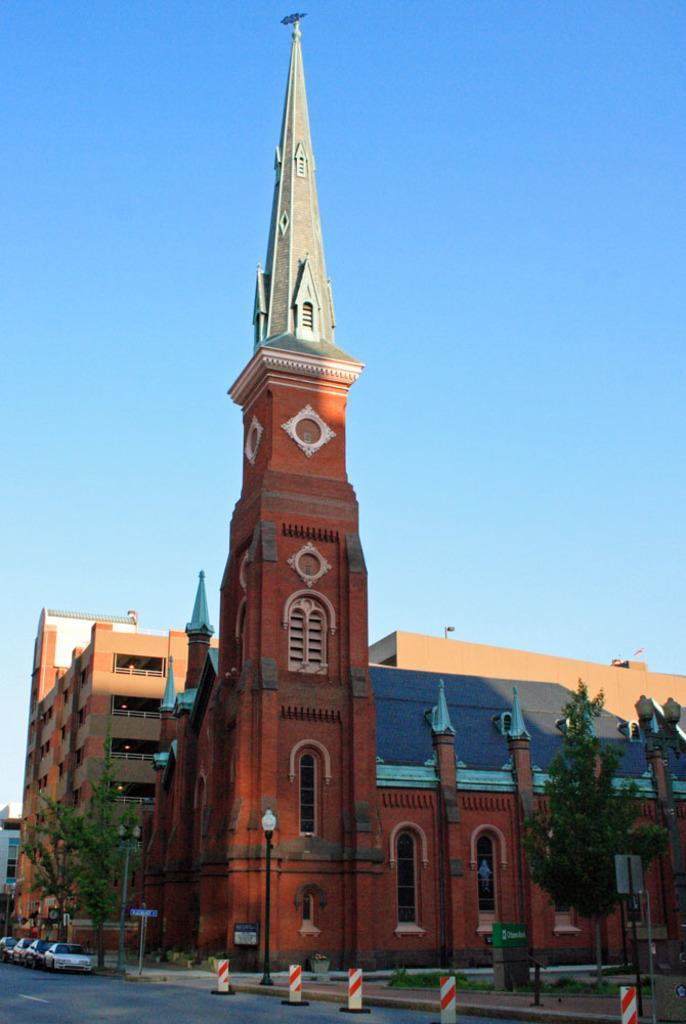In one or two sentences, can you explain what this image depicts? There are cars on the road. Here we can see poles, boards, trees, tower, and buildings. In the background there is sky. 